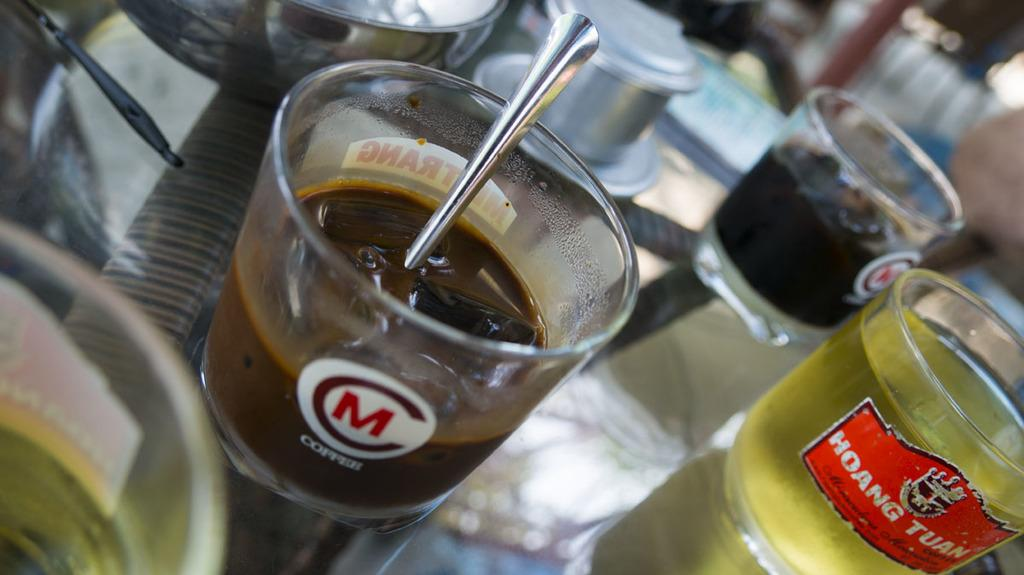<image>
Give a short and clear explanation of the subsequent image. the letter M that is on a glass 